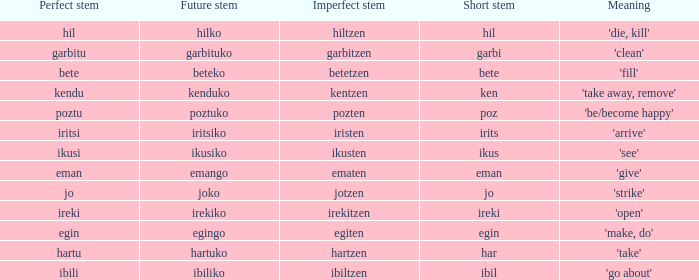What is the number for future stem for poztu? 1.0. 